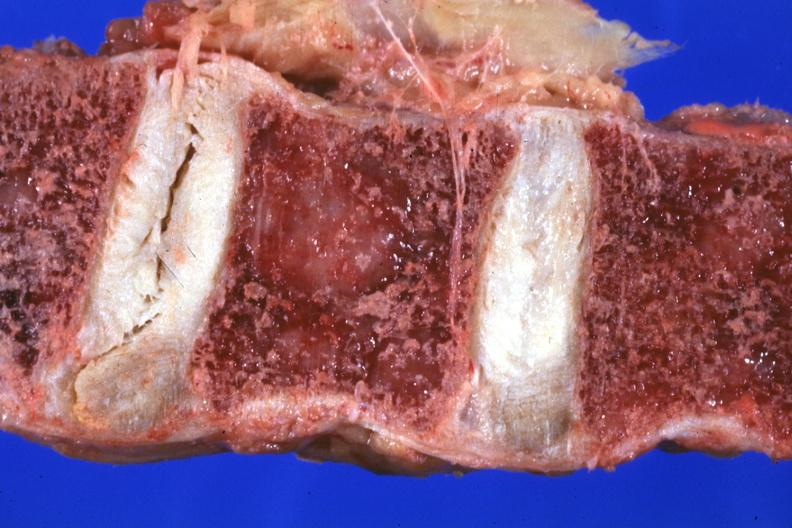does infant body show close-up vertebral body excellent?
Answer the question using a single word or phrase. No 